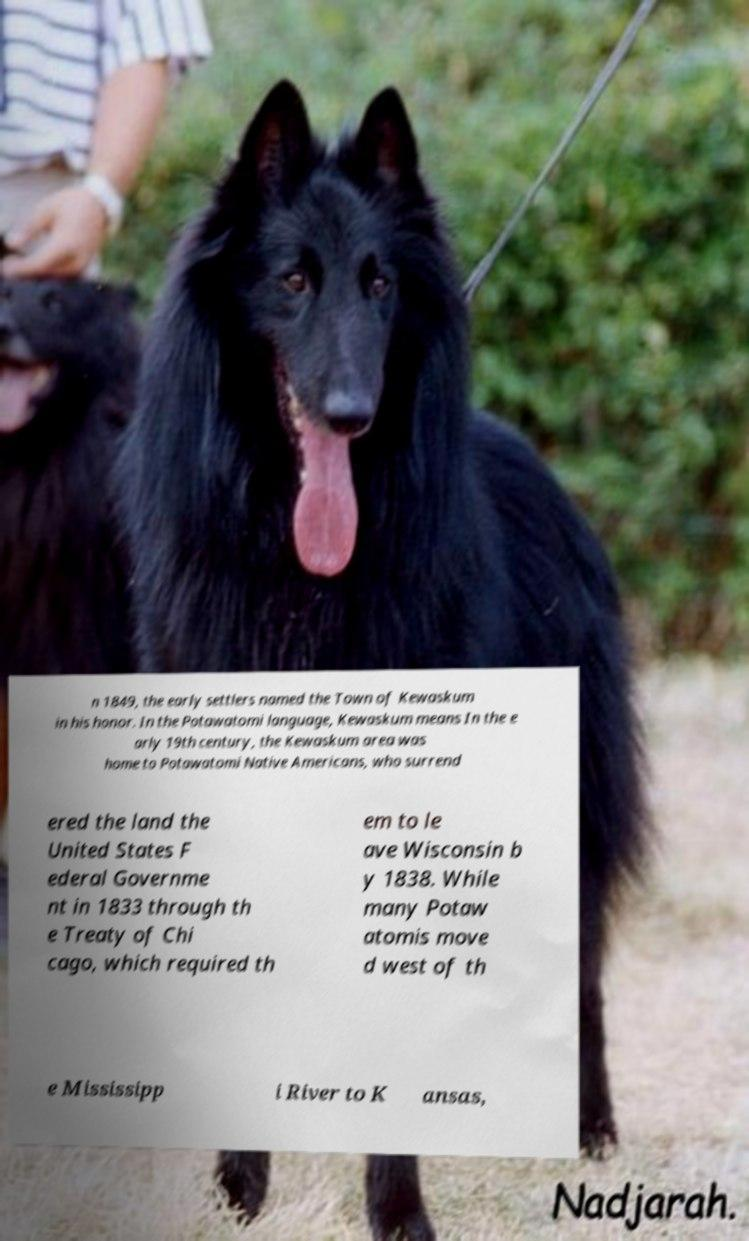Could you assist in decoding the text presented in this image and type it out clearly? n 1849, the early settlers named the Town of Kewaskum in his honor. In the Potawatomi language, Kewaskum means In the e arly 19th century, the Kewaskum area was home to Potawatomi Native Americans, who surrend ered the land the United States F ederal Governme nt in 1833 through th e Treaty of Chi cago, which required th em to le ave Wisconsin b y 1838. While many Potaw atomis move d west of th e Mississipp i River to K ansas, 